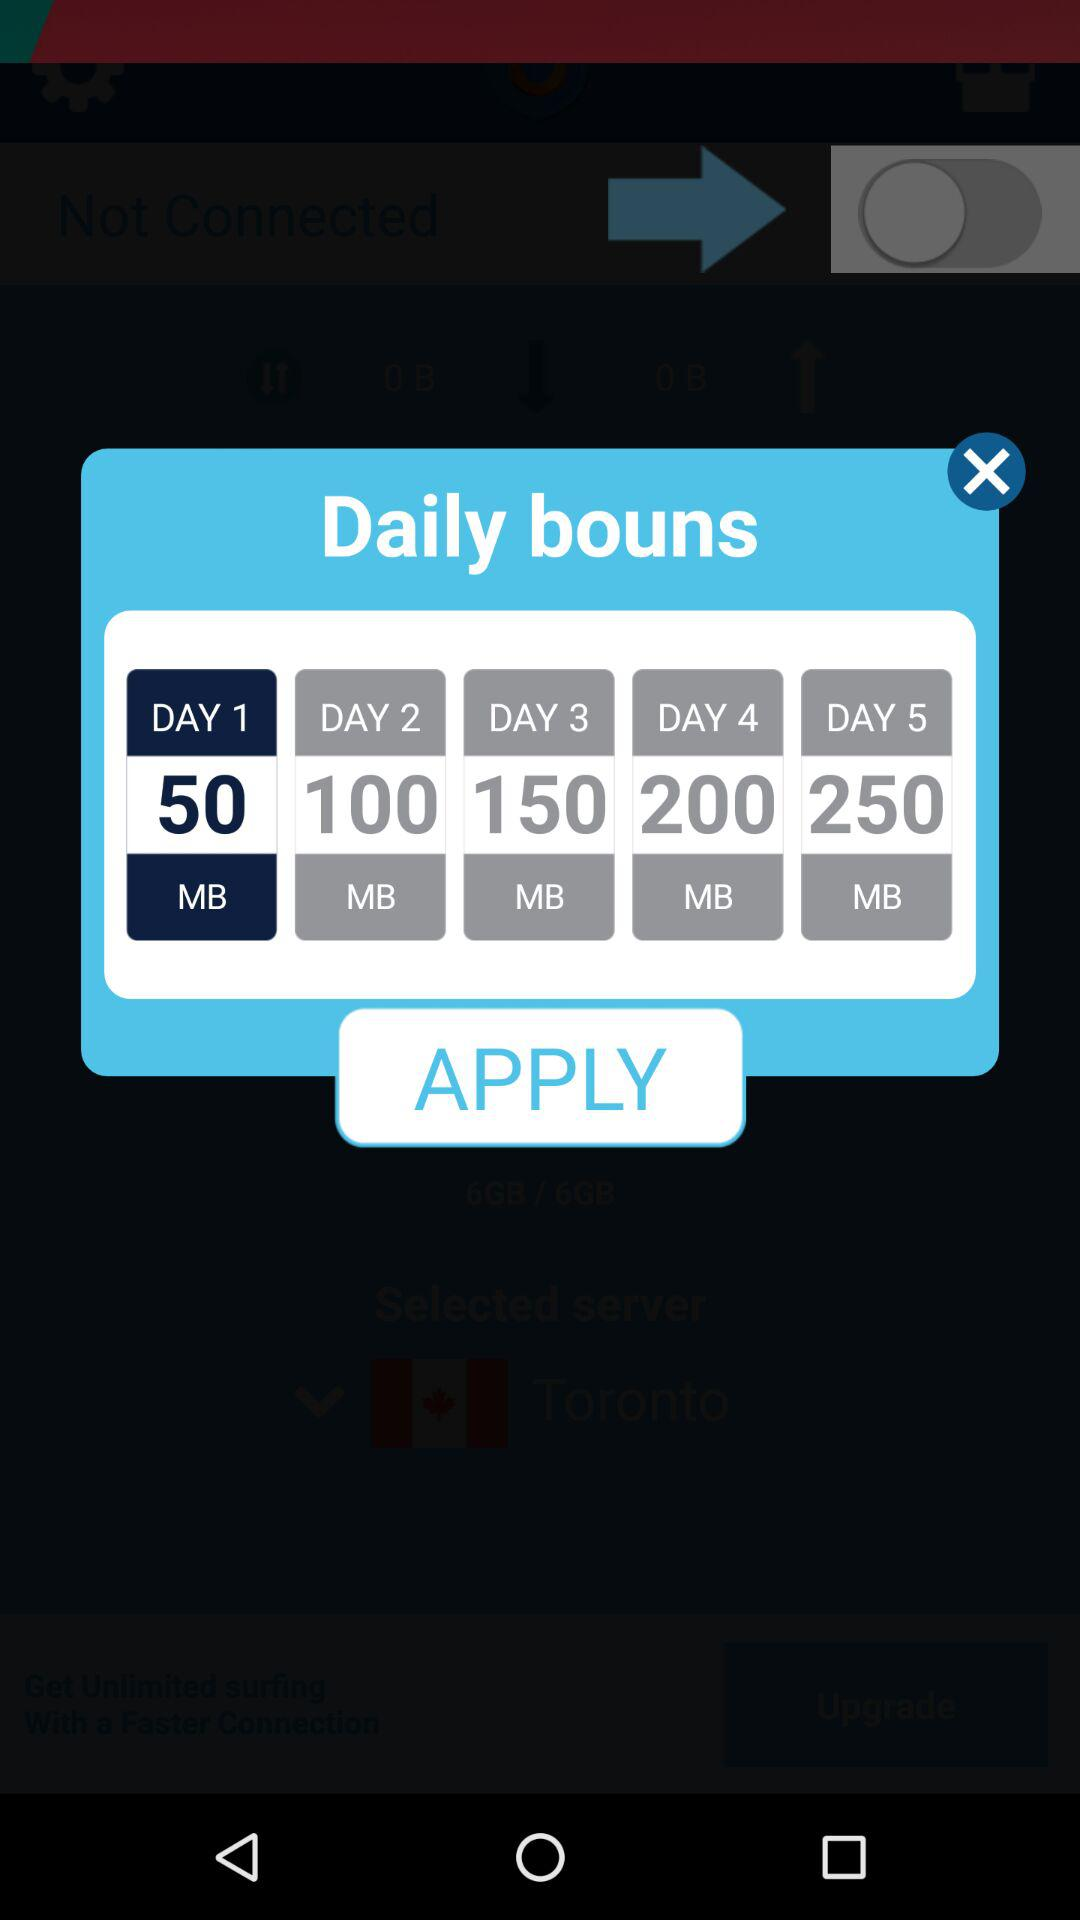How many MB of data is there on the sixth day of the daily bonus?
When the provided information is insufficient, respond with <no answer>. <no answer> 